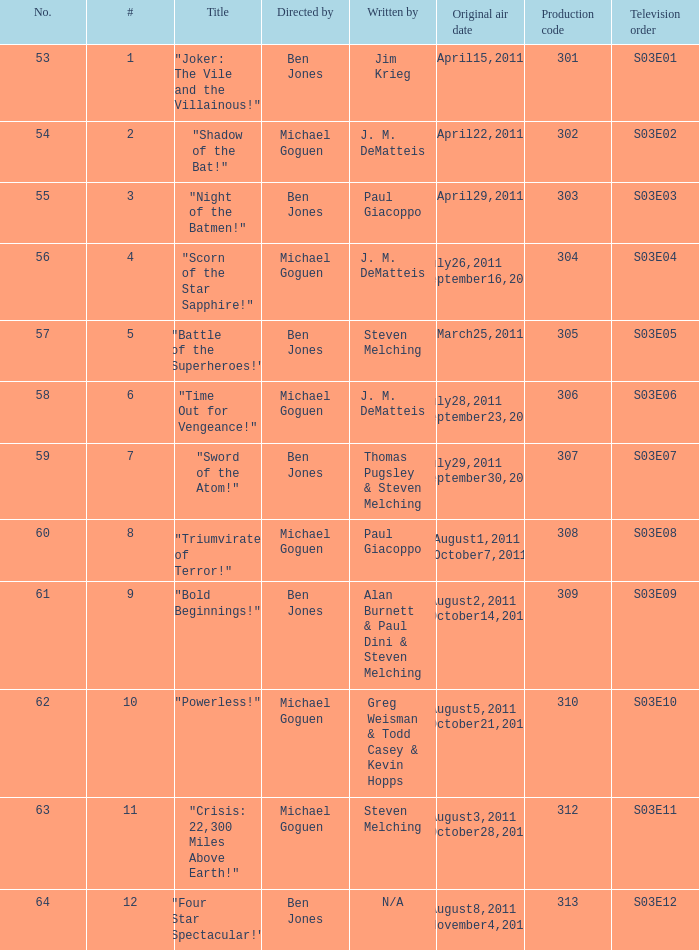What was the original air date for "Crisis: 22,300 Miles Above Earth!"? August3,2011 October28,2011. 